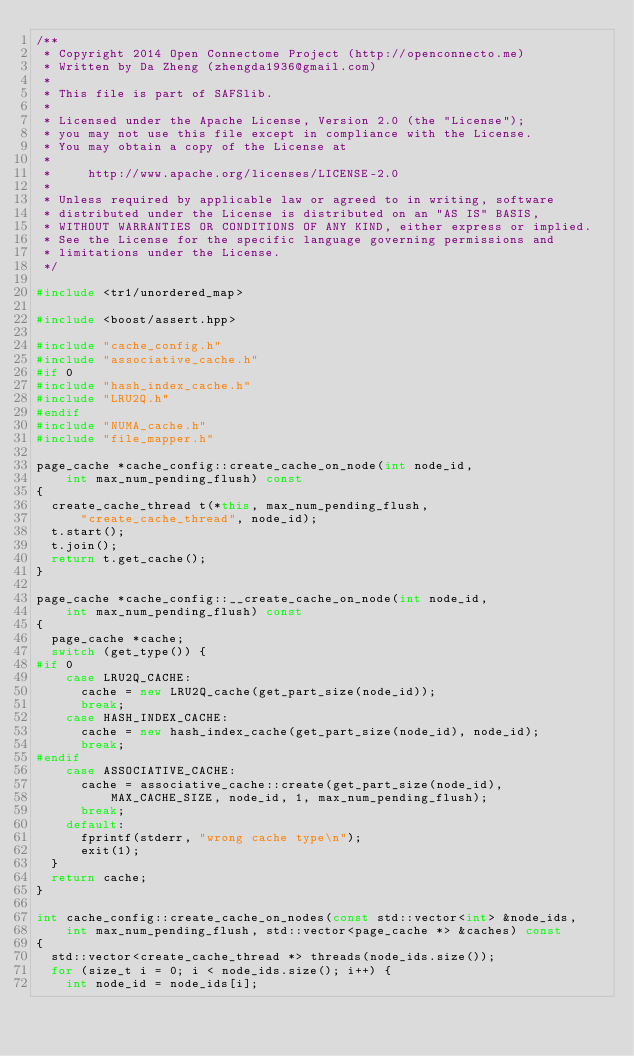Convert code to text. <code><loc_0><loc_0><loc_500><loc_500><_C++_>/**
 * Copyright 2014 Open Connectome Project (http://openconnecto.me)
 * Written by Da Zheng (zhengda1936@gmail.com)
 *
 * This file is part of SAFSlib.
 *
 * Licensed under the Apache License, Version 2.0 (the "License");
 * you may not use this file except in compliance with the License.
 * You may obtain a copy of the License at
 *
 *     http://www.apache.org/licenses/LICENSE-2.0
 *
 * Unless required by applicable law or agreed to in writing, software
 * distributed under the License is distributed on an "AS IS" BASIS,
 * WITHOUT WARRANTIES OR CONDITIONS OF ANY KIND, either express or implied.
 * See the License for the specific language governing permissions and
 * limitations under the License.
 */

#include <tr1/unordered_map>

#include <boost/assert.hpp>

#include "cache_config.h"
#include "associative_cache.h"
#if 0
#include "hash_index_cache.h"
#include "LRU2Q.h"
#endif
#include "NUMA_cache.h"
#include "file_mapper.h"

page_cache *cache_config::create_cache_on_node(int node_id,
		int max_num_pending_flush) const
{
	create_cache_thread t(*this, max_num_pending_flush,
			"create_cache_thread", node_id);
	t.start();
	t.join();
	return t.get_cache();
}

page_cache *cache_config::__create_cache_on_node(int node_id,
		int max_num_pending_flush) const
{
	page_cache *cache;
	switch (get_type()) {
#if 0
		case LRU2Q_CACHE:
			cache = new LRU2Q_cache(get_part_size(node_id));
			break;
		case HASH_INDEX_CACHE:
			cache = new hash_index_cache(get_part_size(node_id), node_id);
			break;
#endif
		case ASSOCIATIVE_CACHE:
			cache = associative_cache::create(get_part_size(node_id),
					MAX_CACHE_SIZE, node_id, 1, max_num_pending_flush);
			break;
		default:
			fprintf(stderr, "wrong cache type\n");
			exit(1);
	}
	return cache;
}

int cache_config::create_cache_on_nodes(const std::vector<int> &node_ids,
		int max_num_pending_flush, std::vector<page_cache *> &caches) const
{
	std::vector<create_cache_thread *> threads(node_ids.size());
	for (size_t i = 0; i < node_ids.size(); i++) {
		int node_id = node_ids[i];</code> 